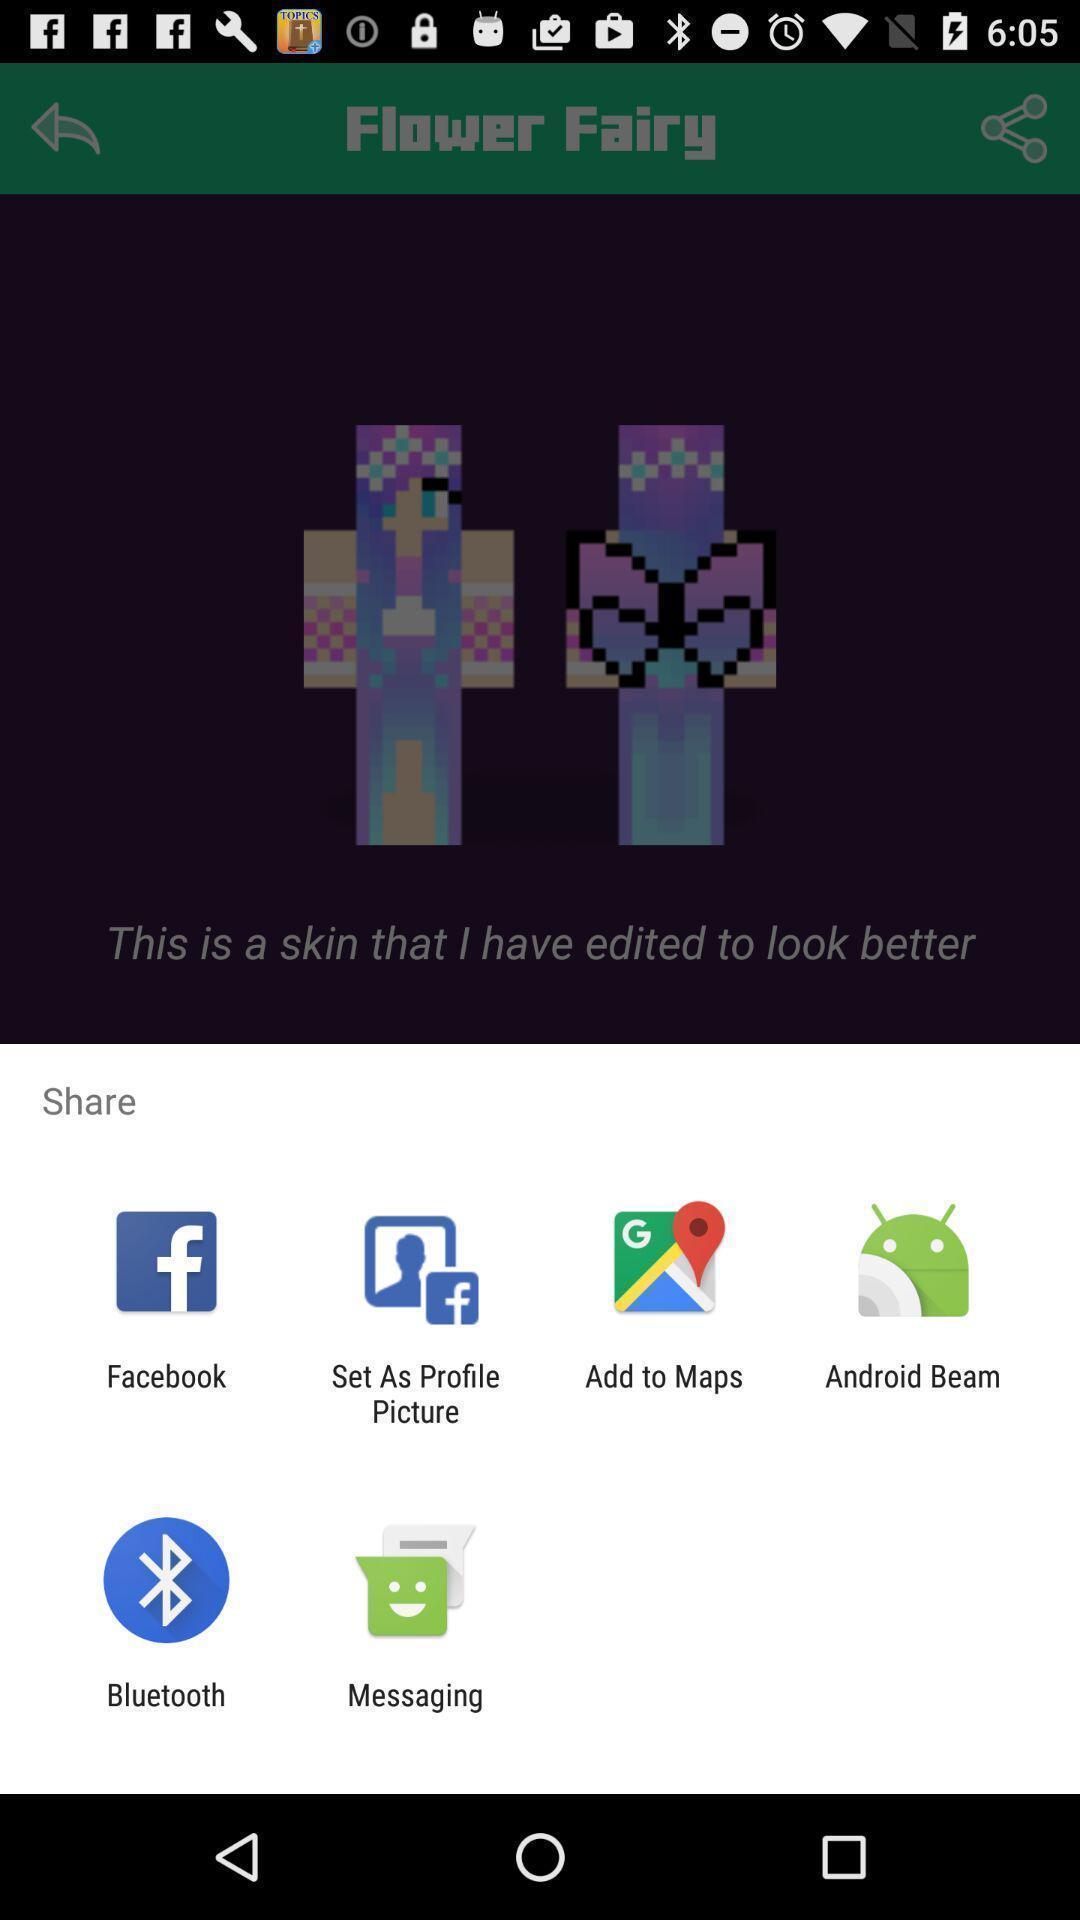Describe the visual elements of this screenshot. Pop-up showing multiple options to share. 